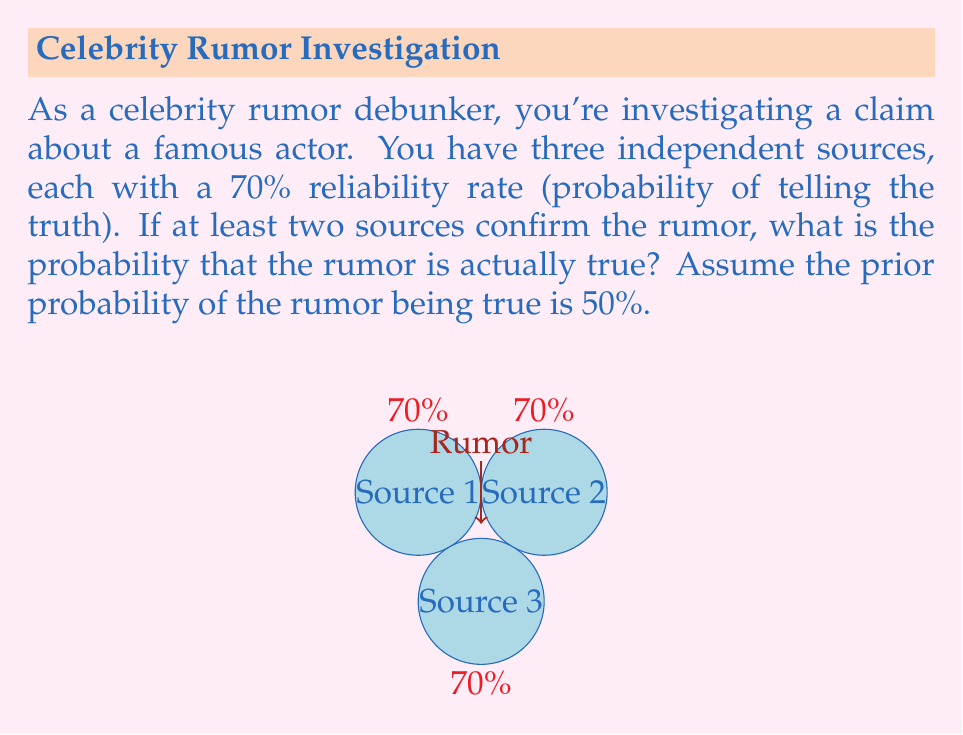Show me your answer to this math problem. Let's approach this step-by-step using Bayes' theorem:

1) Let A be the event that the rumor is true, and B be the event that at least two sources confirm the rumor.

2) We need to calculate $P(A|B)$ using Bayes' theorem:

   $$P(A|B) = \frac{P(B|A)P(A)}{P(B)}$$

3) We're given that $P(A) = 0.5$ (prior probability of the rumor being true)

4) To calculate $P(B|A)$, we need to consider the probability of at least two sources confirming when the rumor is true:
   
   $$P(B|A) = \binom{3}{3}0.7^3 + \binom{3}{2}0.7^2(0.3) = 0.343 + 0.441 = 0.784$$

5) To calculate $P(B)$, we use the law of total probability:
   
   $$P(B) = P(B|A)P(A) + P(B|\text{not }A)P(\text{not }A)$$

6) We already calculated $P(B|A)$. For $P(B|\text{not }A)$, we need the probability of at least two sources confirming when the rumor is false:
   
   $$P(B|\text{not }A) = \binom{3}{3}0.3^3 + \binom{3}{2}0.3^2(0.7) = 0.027 + 0.189 = 0.216$$

7) Now we can calculate $P(B)$:
   
   $$P(B) = 0.784 * 0.5 + 0.216 * 0.5 = 0.5$$

8) Finally, we can apply Bayes' theorem:

   $$P(A|B) = \frac{0.784 * 0.5}{0.5} = 0.784$$

Therefore, the probability that the rumor is true given that at least two sources confirmed it is 0.784 or 78.4%.
Answer: $0.784$ or $78.4\%$ 